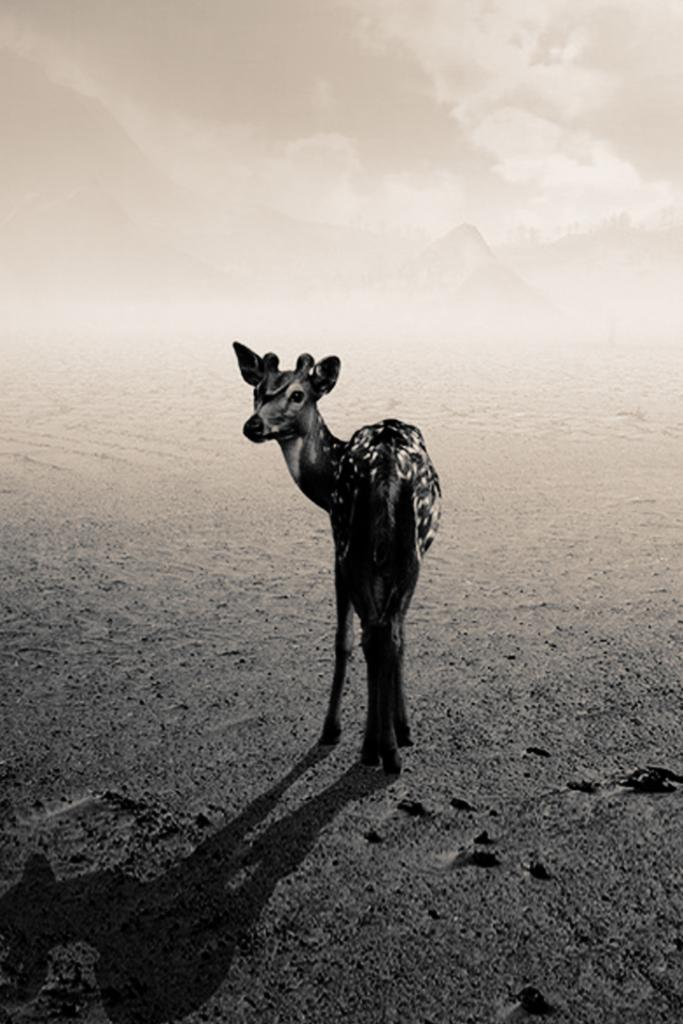What is on the road in the image? There is an animal on the road in the image. What can be seen in the distance in the image? Mountains and the sky are visible in the background of the image. Can you describe the time of day the image may have been taken? The image may have been taken during the night, as suggested by the transcript. What advice does the father give about the animal's development in the image? There is no father present in the image, nor is there any information about the animal's development. 